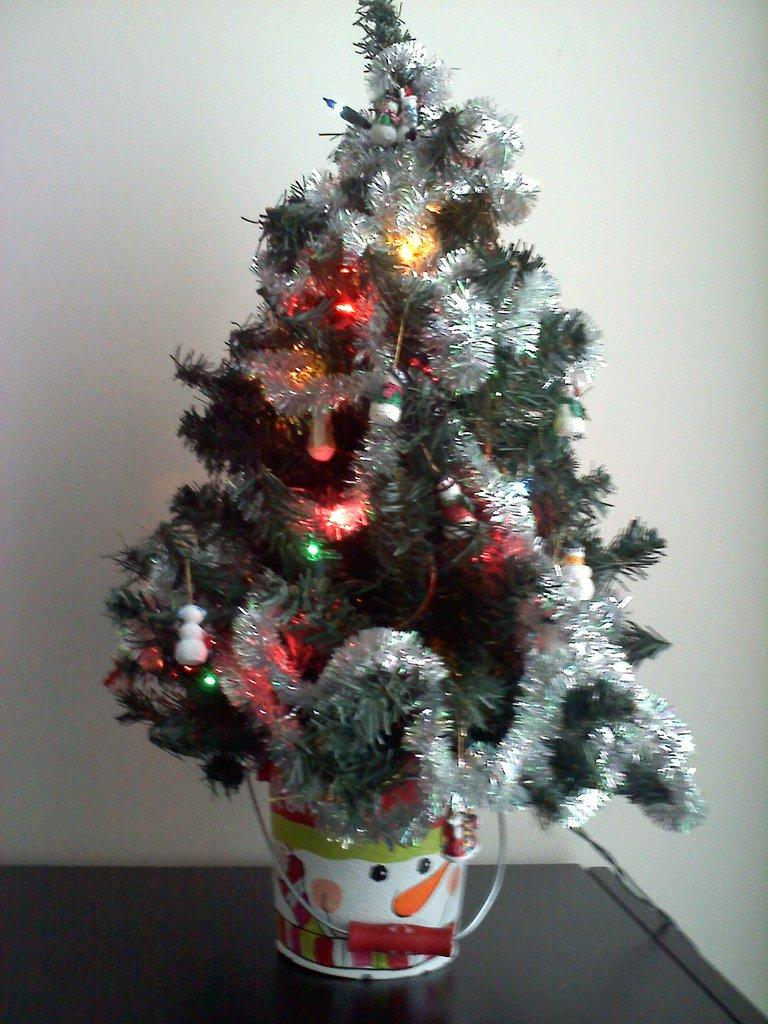What is the main object in the image? There is a Christmas tree in the image. How is the Christmas tree elevated? The Christmas tree is on a platform. What is visible behind the Christmas tree? There is a wall behind the Christmas tree. How many quince are hanging from the Christmas tree in the image? There are no quince present in the image; it features a Christmas tree without any fruits or decorations mentioned. 